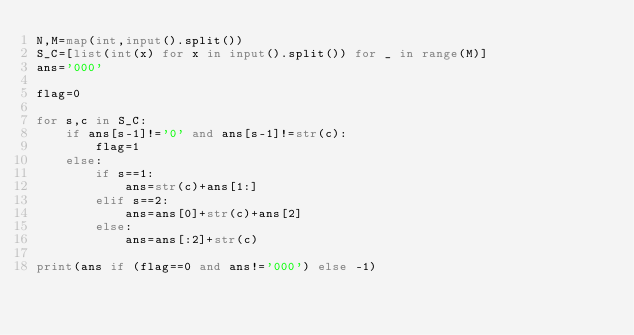<code> <loc_0><loc_0><loc_500><loc_500><_Python_>N,M=map(int,input().split())
S_C=[list(int(x) for x in input().split()) for _ in range(M)]
ans='000'

flag=0

for s,c in S_C:
    if ans[s-1]!='0' and ans[s-1]!=str(c):
        flag=1
    else:
        if s==1:
            ans=str(c)+ans[1:]
        elif s==2:
            ans=ans[0]+str(c)+ans[2]
        else:
            ans=ans[:2]+str(c)

print(ans if (flag==0 and ans!='000') else -1)

</code> 